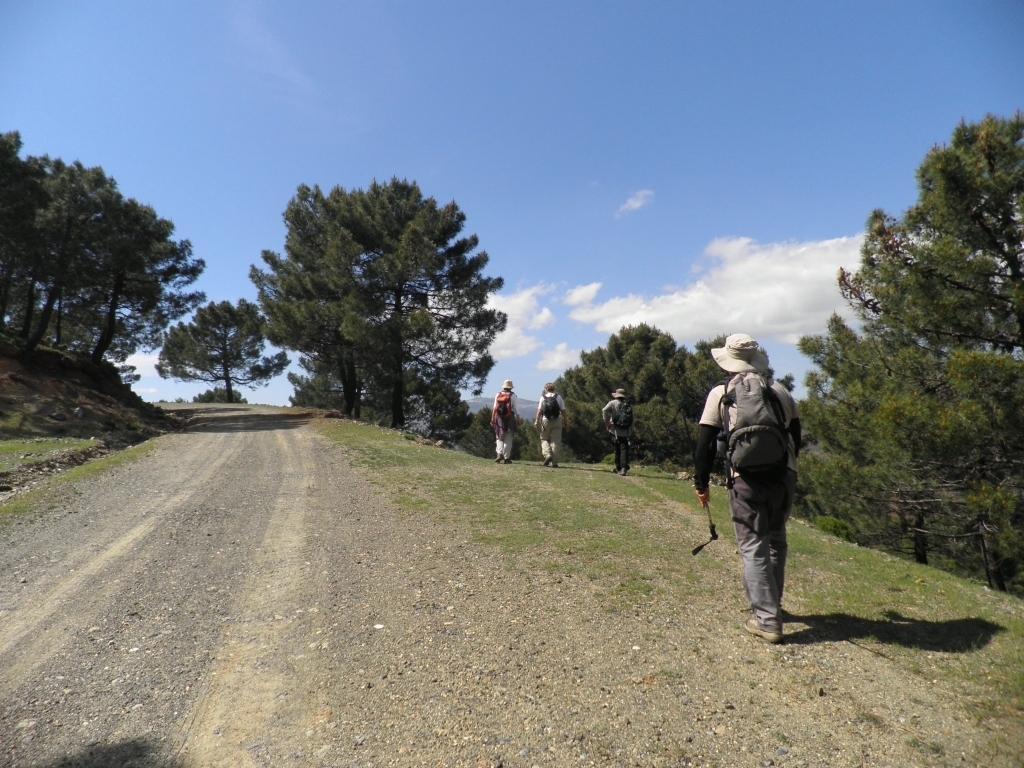Can you describe this image briefly? In this picture we can see some people carrying bags and walking on the ground, trees and in the background we can see the sky with clouds. 